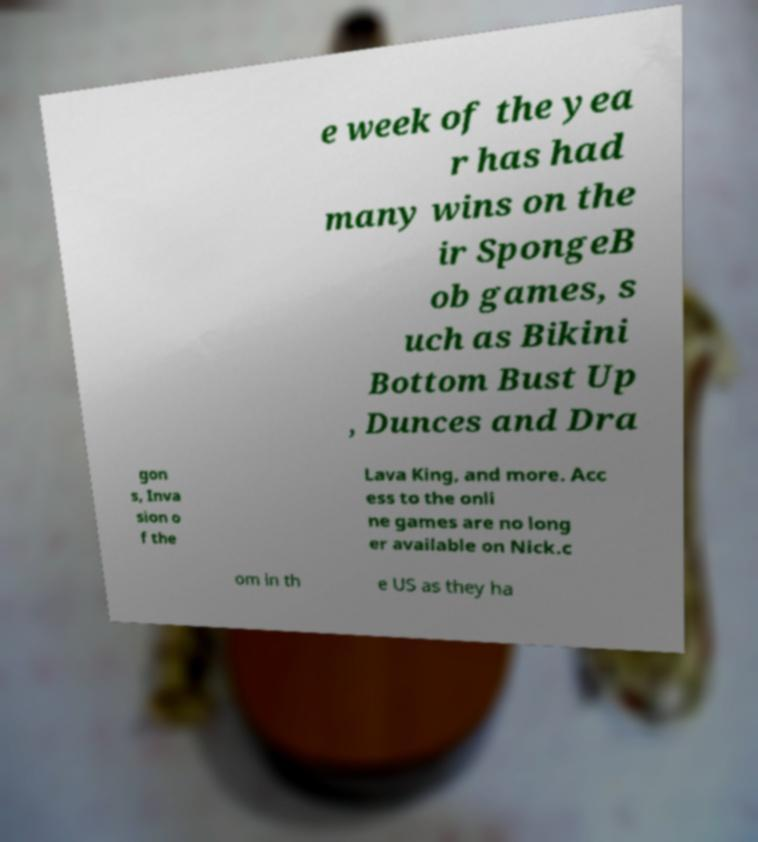What messages or text are displayed in this image? I need them in a readable, typed format. e week of the yea r has had many wins on the ir SpongeB ob games, s uch as Bikini Bottom Bust Up , Dunces and Dra gon s, Inva sion o f the Lava King, and more. Acc ess to the onli ne games are no long er available on Nick.c om in th e US as they ha 